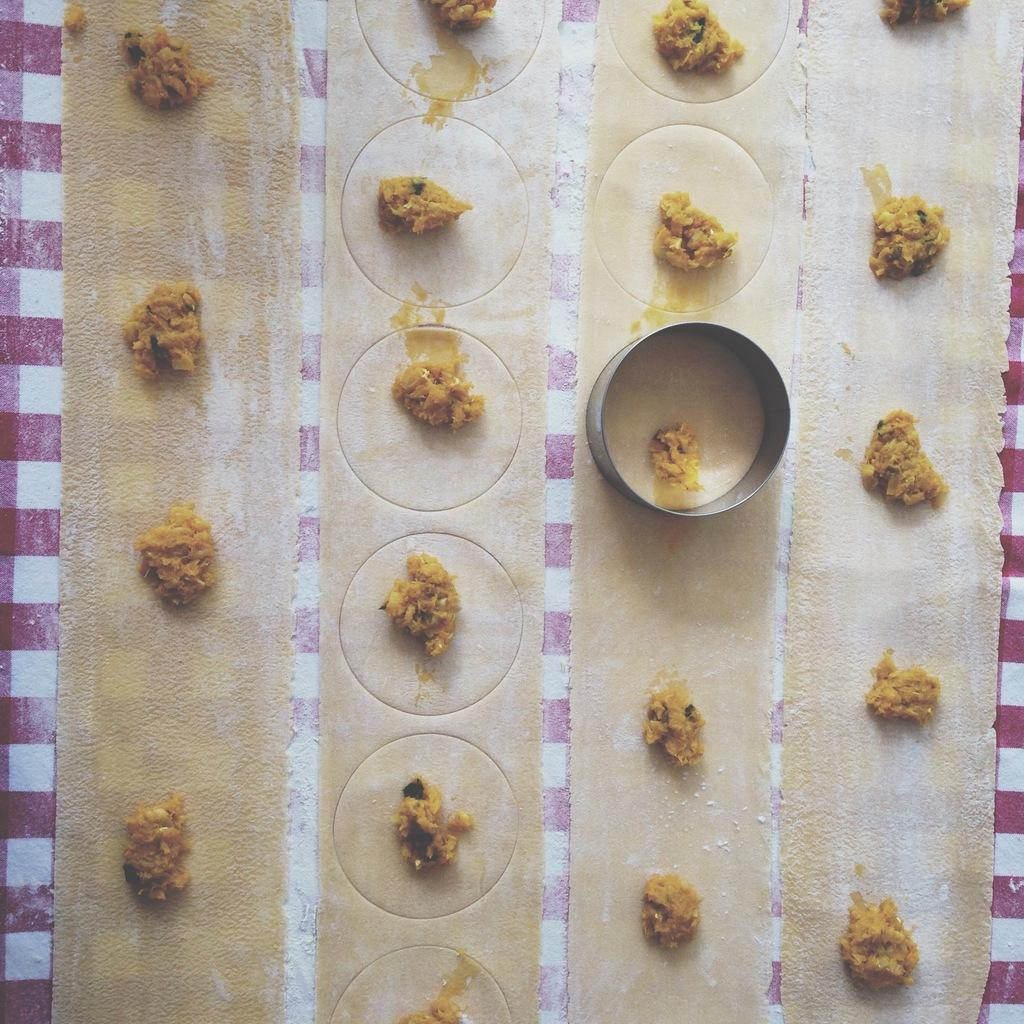What is the color and pattern of the surface in the image? The surface in the image has a red and white striped pattern. What is happening on the surface? A food item is being prepared on the surface. Can you describe the round steel object in the image? There is a round steel object in the image. How many wrens can be seen flying around the round steel object in the image? There are no wrens present in the image, so it is not possible to determine the number of wrens flying around the round steel object. 